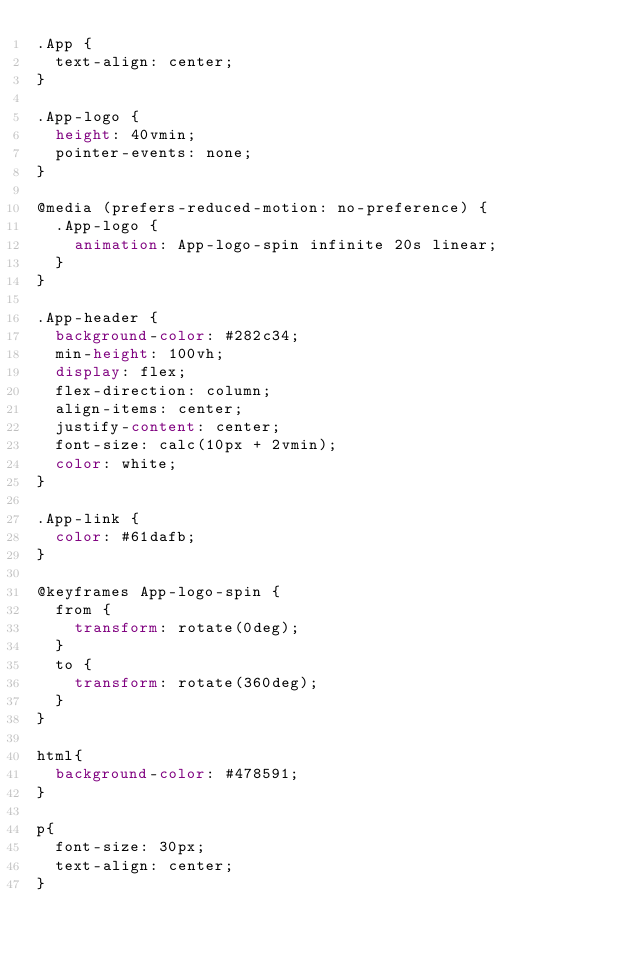<code> <loc_0><loc_0><loc_500><loc_500><_CSS_>.App {
  text-align: center;
}

.App-logo {
  height: 40vmin;
  pointer-events: none;
}

@media (prefers-reduced-motion: no-preference) {
  .App-logo {
    animation: App-logo-spin infinite 20s linear;
  }
}

.App-header {
  background-color: #282c34;
  min-height: 100vh;
  display: flex;
  flex-direction: column;
  align-items: center;
  justify-content: center;
  font-size: calc(10px + 2vmin);
  color: white;
}

.App-link {
  color: #61dafb;
}

@keyframes App-logo-spin {
  from {
    transform: rotate(0deg);
  }
  to {
    transform: rotate(360deg);
  }
}

html{
  background-color: #478591;
}

p{
  font-size: 30px;
  text-align: center;
}
</code> 